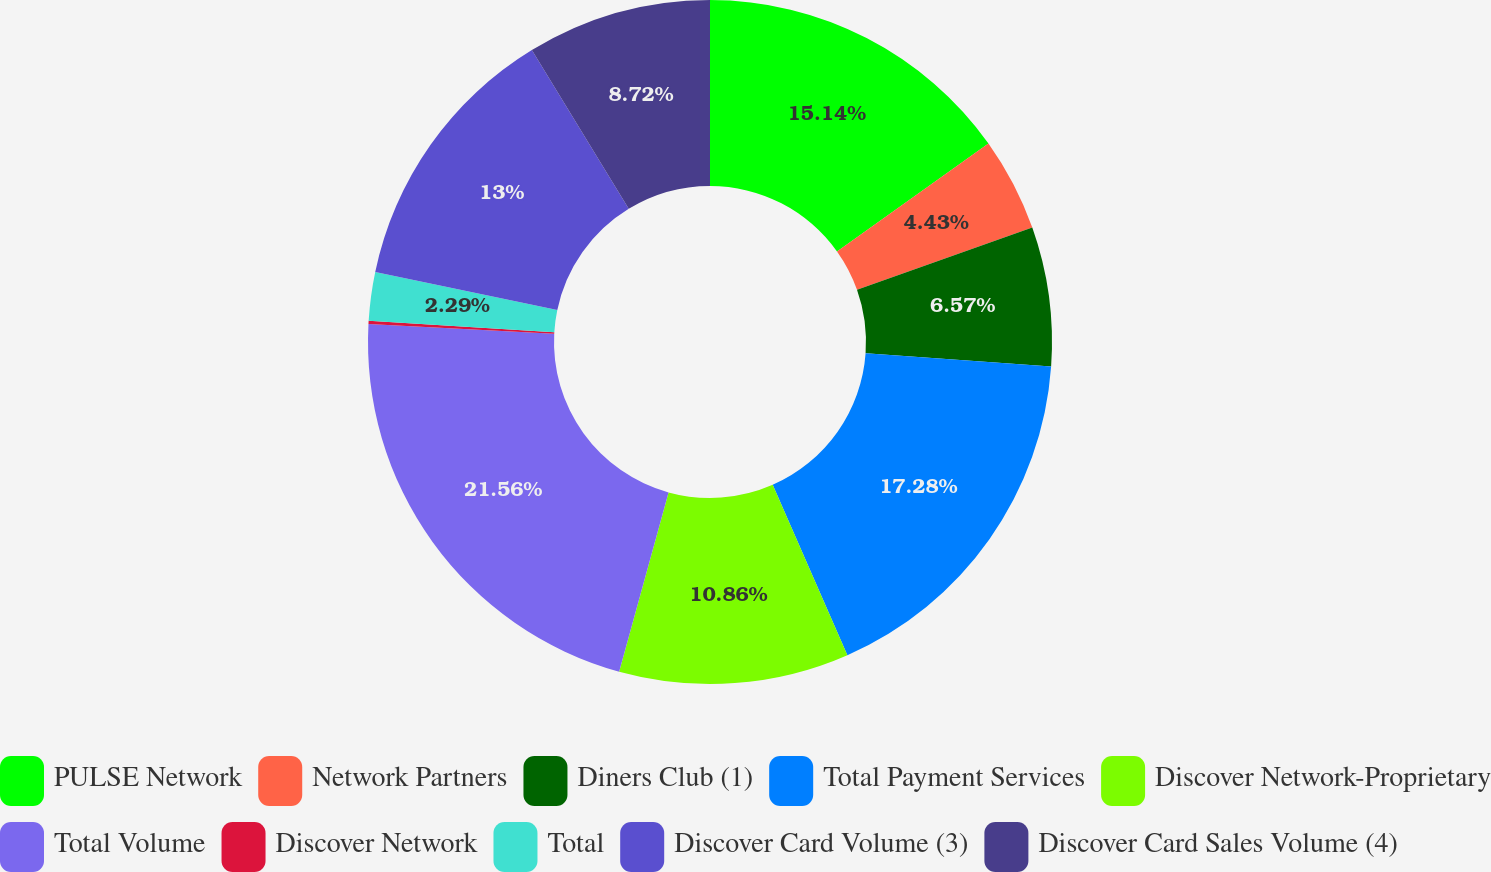<chart> <loc_0><loc_0><loc_500><loc_500><pie_chart><fcel>PULSE Network<fcel>Network Partners<fcel>Diners Club (1)<fcel>Total Payment Services<fcel>Discover Network-Proprietary<fcel>Total Volume<fcel>Discover Network<fcel>Total<fcel>Discover Card Volume (3)<fcel>Discover Card Sales Volume (4)<nl><fcel>15.14%<fcel>4.43%<fcel>6.57%<fcel>17.28%<fcel>10.86%<fcel>21.56%<fcel>0.15%<fcel>2.29%<fcel>13.0%<fcel>8.72%<nl></chart> 